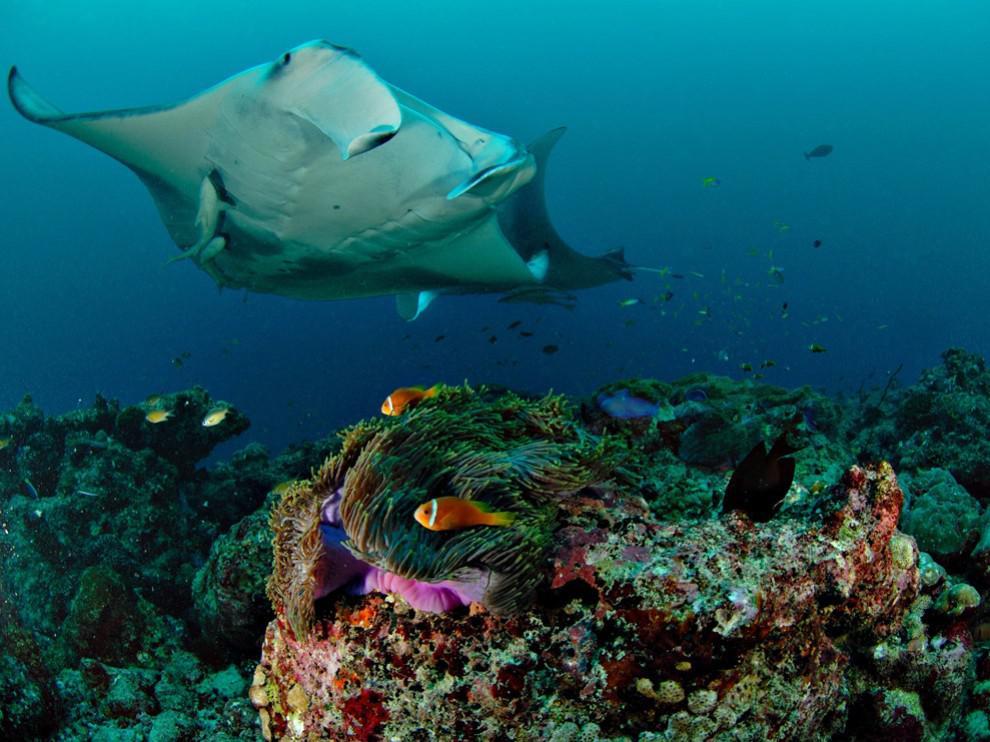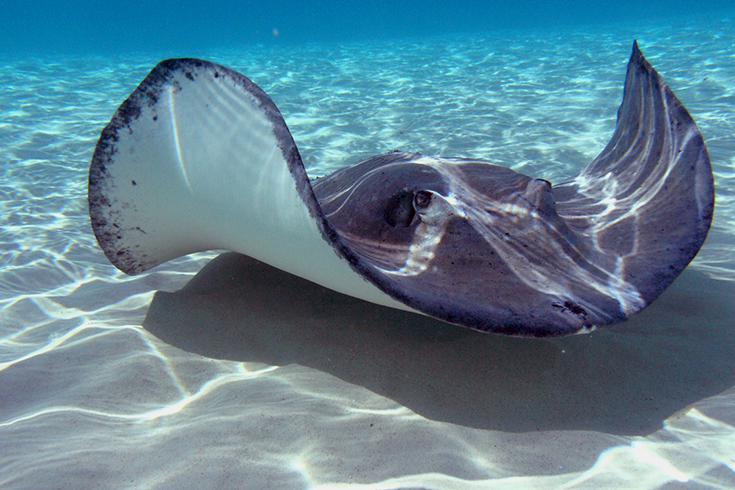The first image is the image on the left, the second image is the image on the right. Considering the images on both sides, is "At least three sting rays are swimming in the water." valid? Answer yes or no. No. The first image is the image on the left, the second image is the image on the right. Considering the images on both sides, is "Each images shows just one stingray in the foreground." valid? Answer yes or no. Yes. 